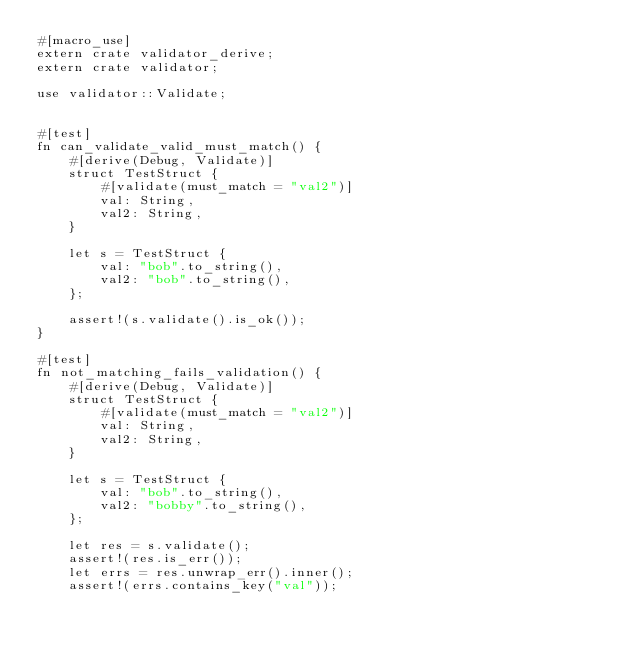<code> <loc_0><loc_0><loc_500><loc_500><_Rust_>#[macro_use]
extern crate validator_derive;
extern crate validator;

use validator::Validate;


#[test]
fn can_validate_valid_must_match() {
    #[derive(Debug, Validate)]
    struct TestStruct {
        #[validate(must_match = "val2")]
        val: String,
        val2: String,
    }

    let s = TestStruct {
        val: "bob".to_string(),
        val2: "bob".to_string(),
    };

    assert!(s.validate().is_ok());
}

#[test]
fn not_matching_fails_validation() {
    #[derive(Debug, Validate)]
    struct TestStruct {
        #[validate(must_match = "val2")]
        val: String,
        val2: String,
    }

    let s = TestStruct {
        val: "bob".to_string(),
        val2: "bobby".to_string(),
    };

    let res = s.validate();
    assert!(res.is_err());
    let errs = res.unwrap_err().inner();
    assert!(errs.contains_key("val"));</code> 